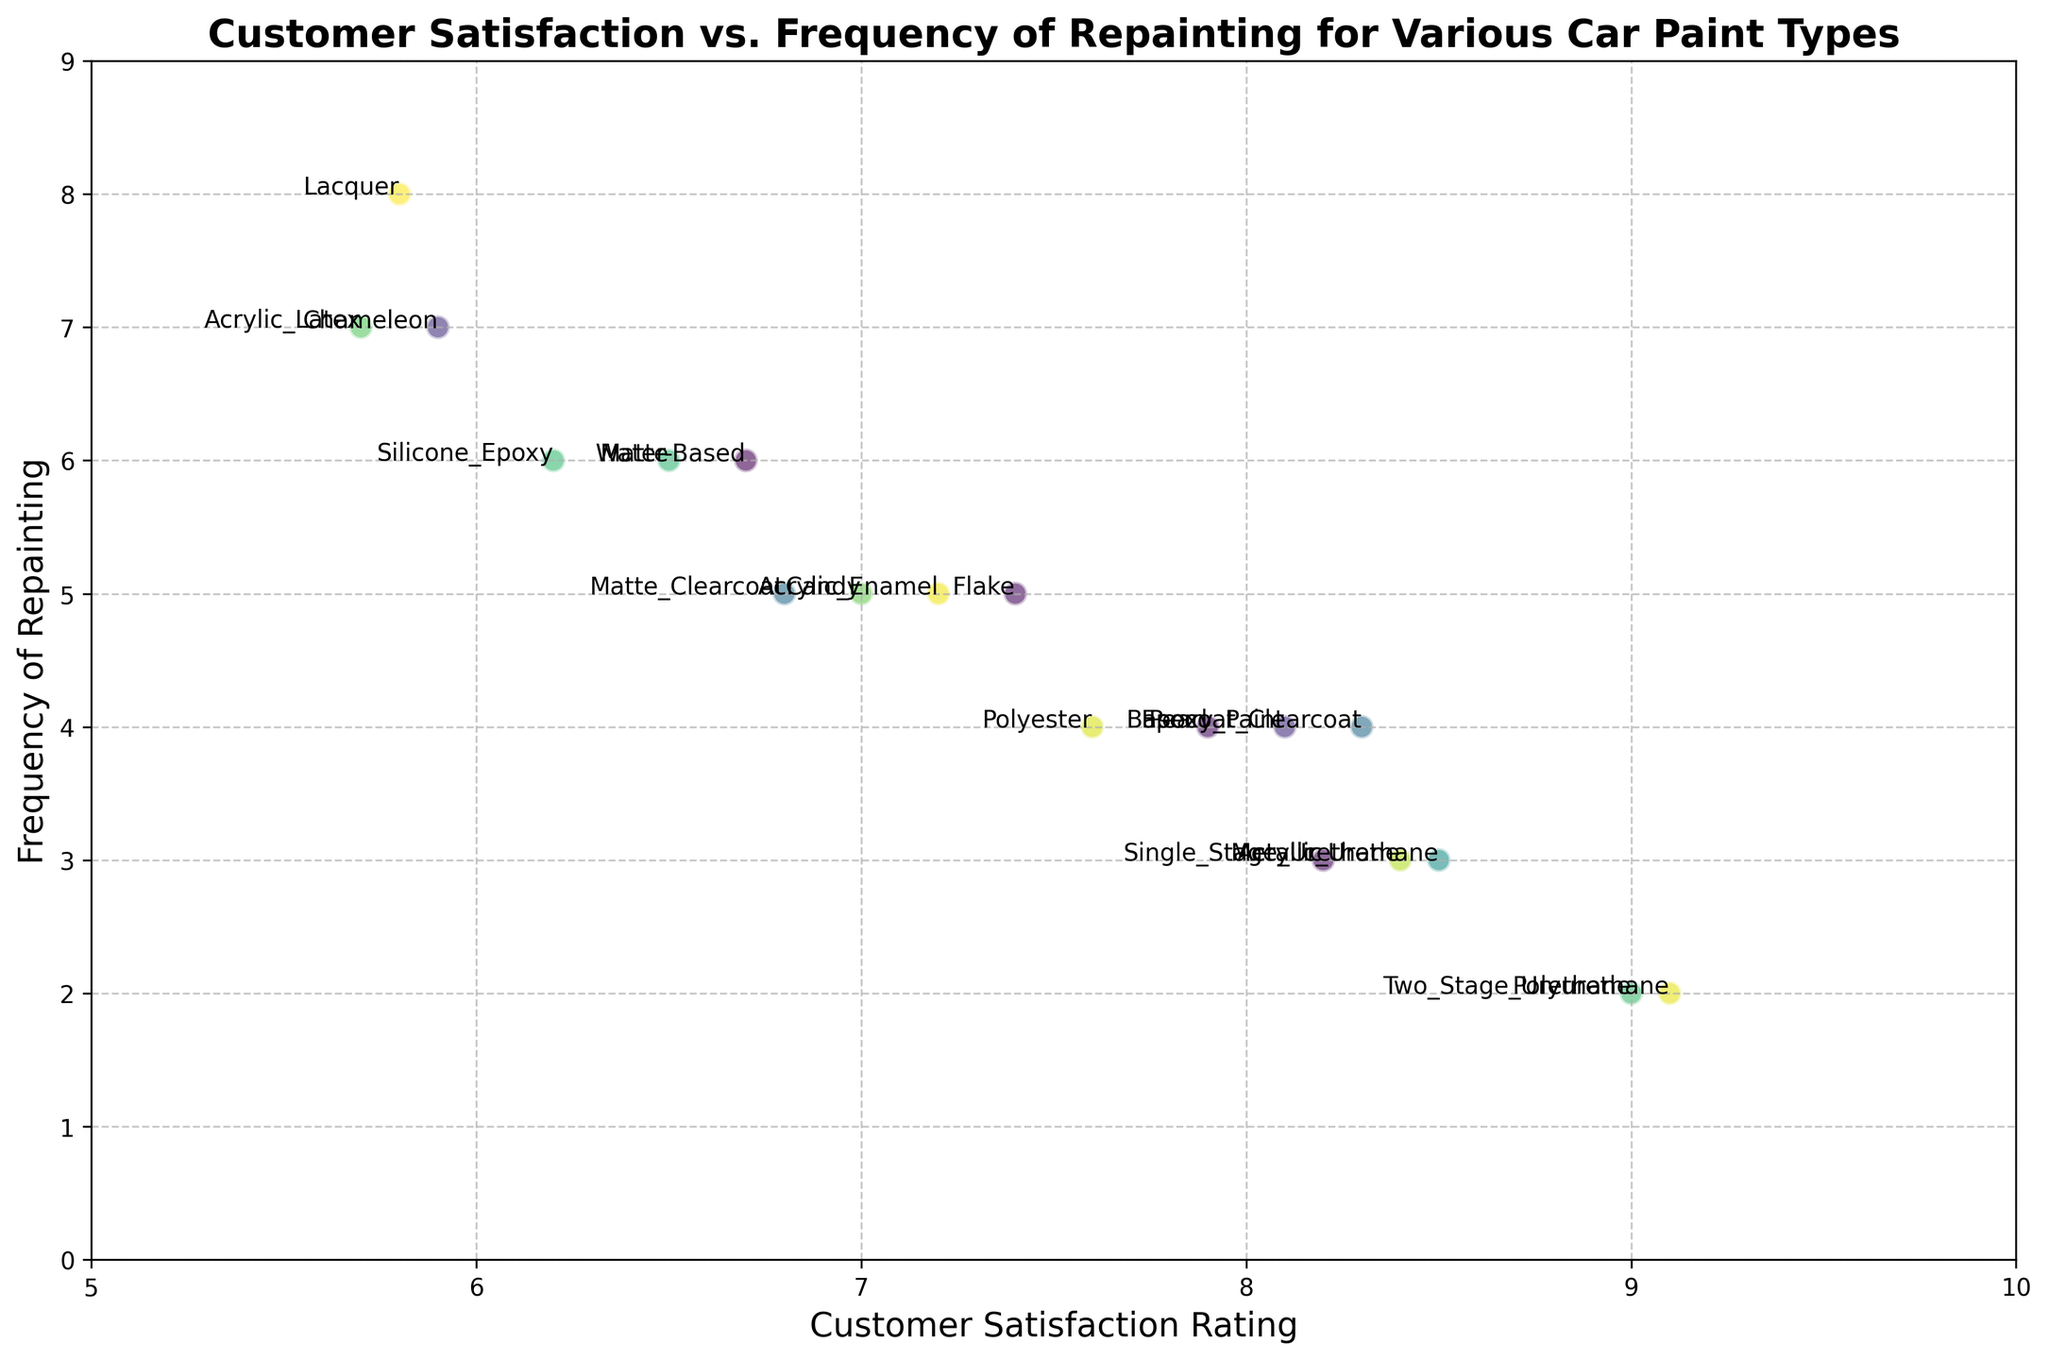Which car paint type has the highest customer satisfaction rating? To find the car paint type with the highest satisfaction rating, look for the point furthest to the right on the x-axis. The point corresponding to 'Polyurethane' is at 9.1.
Answer: Polyurethane Which car paint types need repainting most frequently? Look for the points highest up on the y-axis. 'Lacquer' and 'Chameleon' are at the highest position with values of 8 and 7 respectively.
Answer: Lacquer, Chameleon What car paint type has a satisfaction rating of 7.0? Find the point that is on the x-axis at 7.0. The label indicates this is 'Candy'.
Answer: Candy Which car paint type combines high satisfaction with low repainting frequency and how do you determine it? Look for the points with high customer satisfaction on the right side and low frequency of repainting towards the bottom. 'Two Stage Urethane' and 'Polyurethane' are close to 9.0 and 2 respectively. Among these, 'Polyurethane' has the highest satisfaction rating of 9.1.
Answer: Polyurethane Which car paint type has a satisfaction rating closest to 8 but requires painting 4 times? Look for points around the x-axis of 8 and y-axis of 4. The point ‘Epoxy Paint’ is close with these measures: satisfaction of 8.1 and repainting frequency of 4.
Answer: Epoxy Paint How does the satisfaction rating of 'Matte Clearcoat' compare with 'Matte'? Compare the positions of 'Matte Clearcoat' and 'Matte' on the x-axis. 'Matte Clearcoat' has a satisfaction rating of 6.8, while 'Matte' has 6.5.
Answer: Matte Clearcoat > Matte Which car paint type has the closest satisfaction rating and repainting frequency pair? To find this, look for points where the x and y values are nearest to each other. The point 'Acrylic Latex' has a satisfaction rating of 5.7 and repainting frequency of 7, making it relatively close.
Answer: Acrylic Latex If you average the satisfaction ratings of 'Acrylic Urethane' and 'Single Stage Urethane', what do you get? Satisfaction ratings are 8.5 and 8.4 respectively. Average these by computing (8.5 + 8.4) / 2.
Answer: 8.45 Which car paint type needs repainting more frequently: 'Water-Based' or 'Metallic'? Compare the repainting frequencies. 'Water-Based' has a frequency of 6, and 'Metallic' has 3.
Answer: Water-Based 